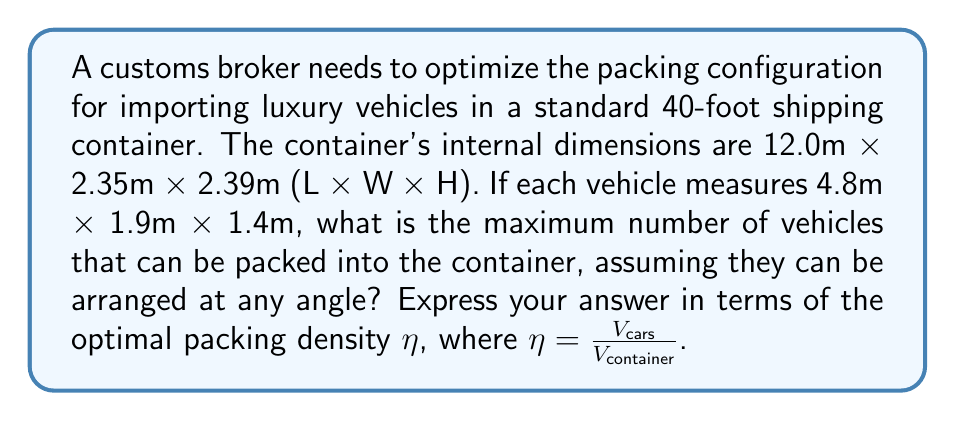Solve this math problem. 1. Calculate the volume of the container:
   $$V_{container} = 12.0 \times 2.35 \times 2.39 = 67.386 \text{ m}^3$$

2. Calculate the volume of each car:
   $$V_{car} = 4.8 \times 1.9 \times 1.4 = 12.768 \text{ m}^3$$

3. The optimal packing density $\eta$ for randomly oriented ellipsoids (which we can approximate our cars as) is approximately 0.65 according to geometric optimization studies.

4. Calculate the total volume of cars that can fit:
   $$V_{cars} = \eta \times V_{container} = 0.65 \times 67.386 = 43.8009 \text{ m}^3$$

5. Calculate the number of cars:
   $$N_{cars} = \frac{V_{cars}}{V_{car}} = \frac{43.8009}{12.768} \approx 3.43$$

6. Since we can't have a fractional car, we round down to 3 cars.

7. Recalculate the actual packing density:
   $$\eta_{actual} = \frac{3 \times V_{car}}{V_{container}} = \frac{3 \times 12.768}{67.386} \approx 0.5685$$
Answer: 3 cars; $\eta_{actual} \approx 0.5685$ 